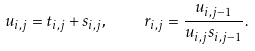Convert formula to latex. <formula><loc_0><loc_0><loc_500><loc_500>u _ { i , j } = t _ { i , j } + s _ { i , j } , \quad r _ { i , j } = \frac { u _ { i , j - 1 } } { u _ { i , j } s _ { i , j - 1 } } .</formula> 